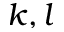<formula> <loc_0><loc_0><loc_500><loc_500>k , l</formula> 